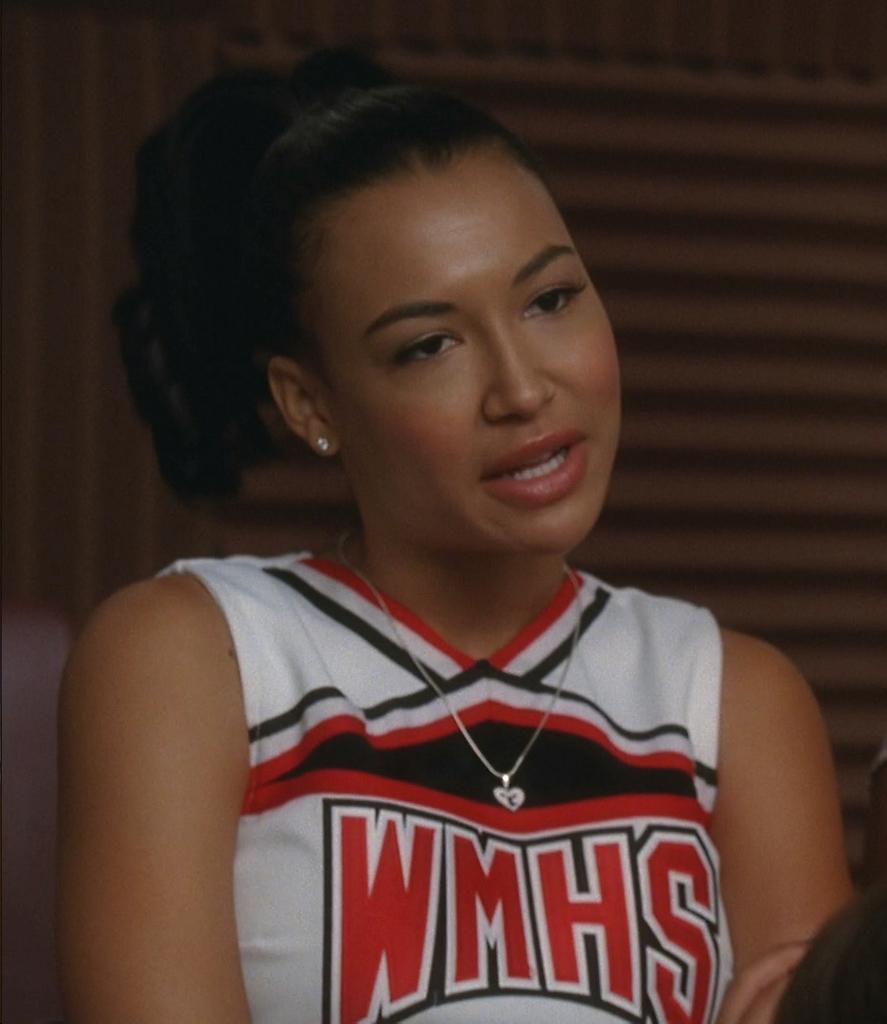What are the initials for the high school she goes to?
Make the answer very short. Wmhs. 